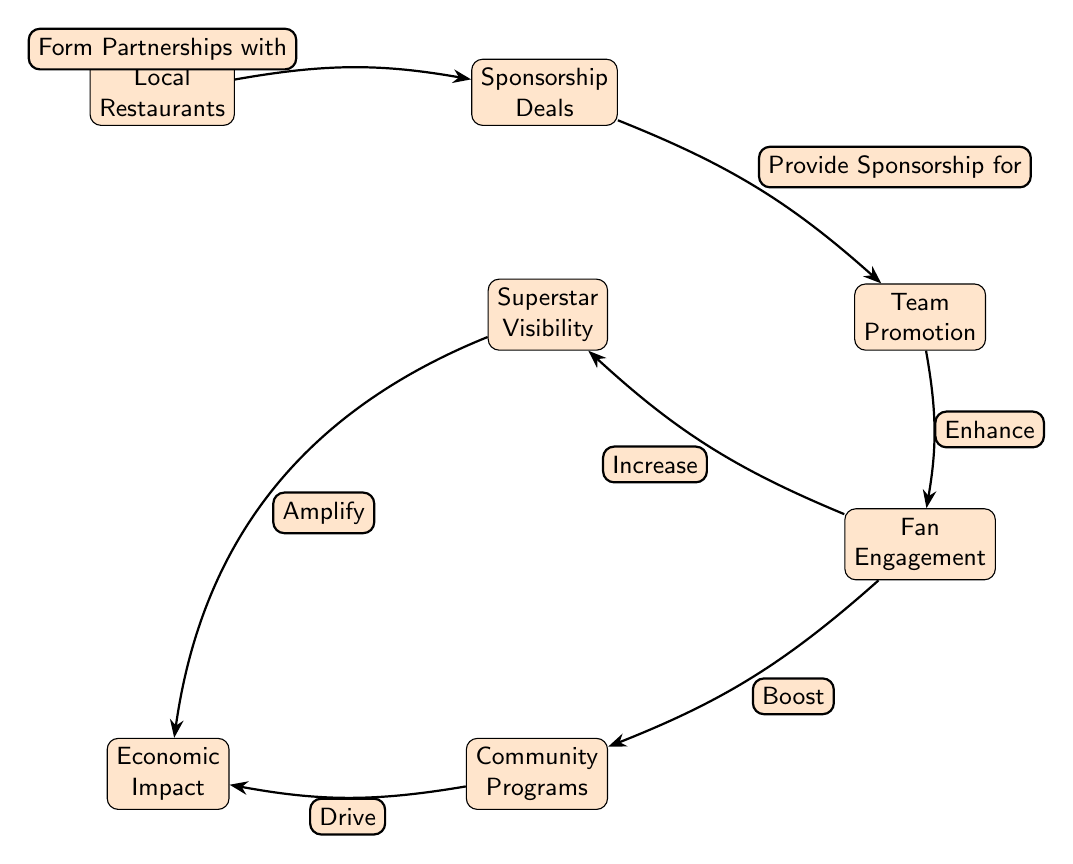What is the first node in the diagram? The first node listed in the diagram is Local Restaurants. Therefore, the answer is based directly on the placement of the nodes starting from the left.
Answer: Local Restaurants How many nodes are in the diagram? By counting each distinct node in the diagram, we identify seven individual nodes. Thus, the total count is derived from the nodes listed in the diagram.
Answer: 7 What is the relationship between "Superstar Visibility" and "Fan Engagement"? The edge connecting "Superstar Visibility" to "Fan Engagement" indicates that "Superstar Visibility" increases "Fan Engagement." Therefore, we highlight the nature of the relationship from the diagram flows.
Answer: Increase What node does "Community Programs" drive to? By following the edge labels, we see that "Community Programs" drives to "Economic Impact." Thus, the driving effect specified in the node relationship leads us to the next relevant node.
Answer: Economic Impact What boosts "Community Programs"? The flow indicates that "Fan Engagement" boosts "Community Programs," highlighting the direct correlation between these two nodes in the diagram. Hence, we determine the source of the boost effect.
Answer: Fan Engagement What does "Sponsorship Deals" provide for "Team Promotion"? The diagram shows that "Sponsorship Deals" provides sponsorship for "Team Promotion," representing a clear function of one node towards another based on edge descriptions.
Answer: Provide Sponsorship for How does "Local Restaurants" influence "Sponsorship Deals"? The edge shows that "Local Restaurants" form partnerships with "Sponsorship Deals." Thus, we trace the diagram back to identify the initiating relationship type.
Answer: Form Partnerships with What amplifies the "Economic Impact"? Following the arrows, we see that "Superstar Visibility" amplifies the "Economic Impact," establishing a connection that emphasizes this specific effect in the diagram structure.
Answer: Amplify 